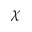<formula> <loc_0><loc_0><loc_500><loc_500>\chi</formula> 